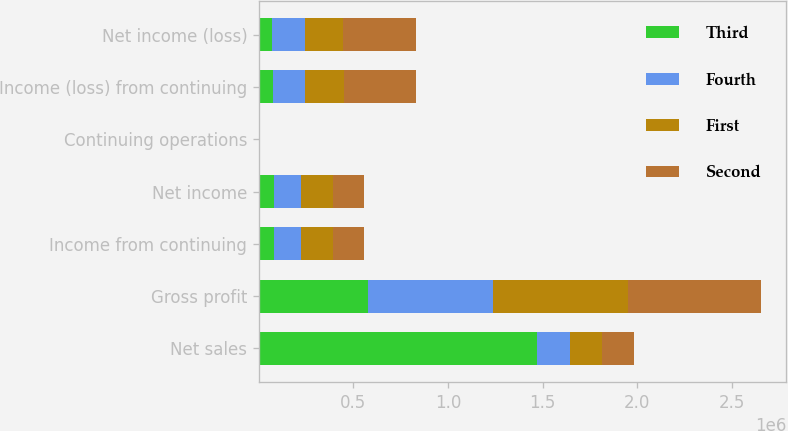<chart> <loc_0><loc_0><loc_500><loc_500><stacked_bar_chart><ecel><fcel>Net sales<fcel>Gross profit<fcel>Income from continuing<fcel>Net income<fcel>Continuing operations<fcel>Income (loss) from continuing<fcel>Net income (loss)<nl><fcel>Third<fcel>1.4715e+06<fcel>578921<fcel>79409<fcel>79409<fcel>0.22<fcel>73082<fcel>70617<nl><fcel>Fourth<fcel>171421<fcel>659956<fcel>140633<fcel>140633<fcel>0.39<fcel>172164<fcel>172532<nl><fcel>First<fcel>171421<fcel>712667<fcel>171421<fcel>171421<fcel>0.47<fcel>203356<fcel>203356<nl><fcel>Second<fcel>171421<fcel>704975<fcel>161621<fcel>161621<fcel>0.44<fcel>384611<fcel>384611<nl></chart> 